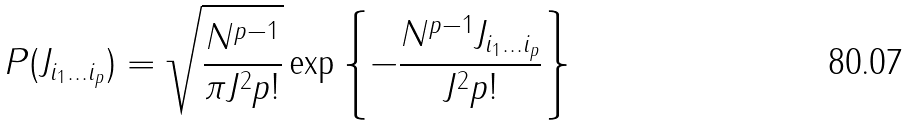<formula> <loc_0><loc_0><loc_500><loc_500>P ( J _ { i _ { 1 } \dots i _ { p } } ) = \sqrt { \frac { N ^ { p - 1 } } { \pi J ^ { 2 } p ! } } \exp \left \{ - \frac { N ^ { p - 1 } J _ { i _ { 1 } \dots i _ { p } } } { J ^ { 2 } p ! } \right \}</formula> 